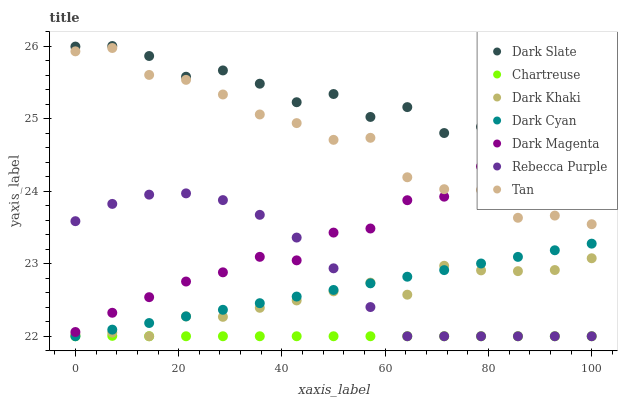Does Chartreuse have the minimum area under the curve?
Answer yes or no. Yes. Does Dark Slate have the maximum area under the curve?
Answer yes or no. Yes. Does Dark Khaki have the minimum area under the curve?
Answer yes or no. No. Does Dark Khaki have the maximum area under the curve?
Answer yes or no. No. Is Dark Cyan the smoothest?
Answer yes or no. Yes. Is Dark Slate the roughest?
Answer yes or no. Yes. Is Dark Khaki the smoothest?
Answer yes or no. No. Is Dark Khaki the roughest?
Answer yes or no. No. Does Dark Khaki have the lowest value?
Answer yes or no. Yes. Does Dark Slate have the lowest value?
Answer yes or no. No. Does Dark Slate have the highest value?
Answer yes or no. Yes. Does Dark Khaki have the highest value?
Answer yes or no. No. Is Chartreuse less than Dark Slate?
Answer yes or no. Yes. Is Tan greater than Chartreuse?
Answer yes or no. Yes. Does Dark Slate intersect Dark Magenta?
Answer yes or no. Yes. Is Dark Slate less than Dark Magenta?
Answer yes or no. No. Is Dark Slate greater than Dark Magenta?
Answer yes or no. No. Does Chartreuse intersect Dark Slate?
Answer yes or no. No. 